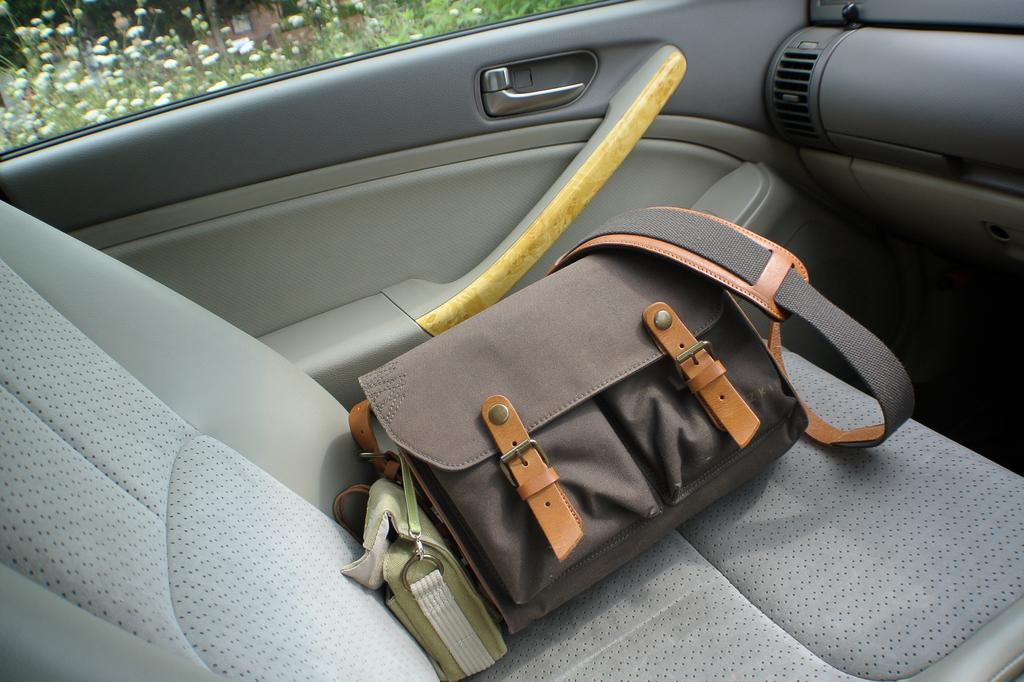What is the setting of the image? The image shows the inside view of a car. What can be seen inside the car? There is a bag in the car. Are there any living organisms visible in the image? Yes, there are plants visible in the image. Can you tell me how many pigs are visible in the image? There are no pigs present in the image; it shows the inside view of a car with a bag and plants. Is there any poison visible in the image? There is no poison present in the image. 